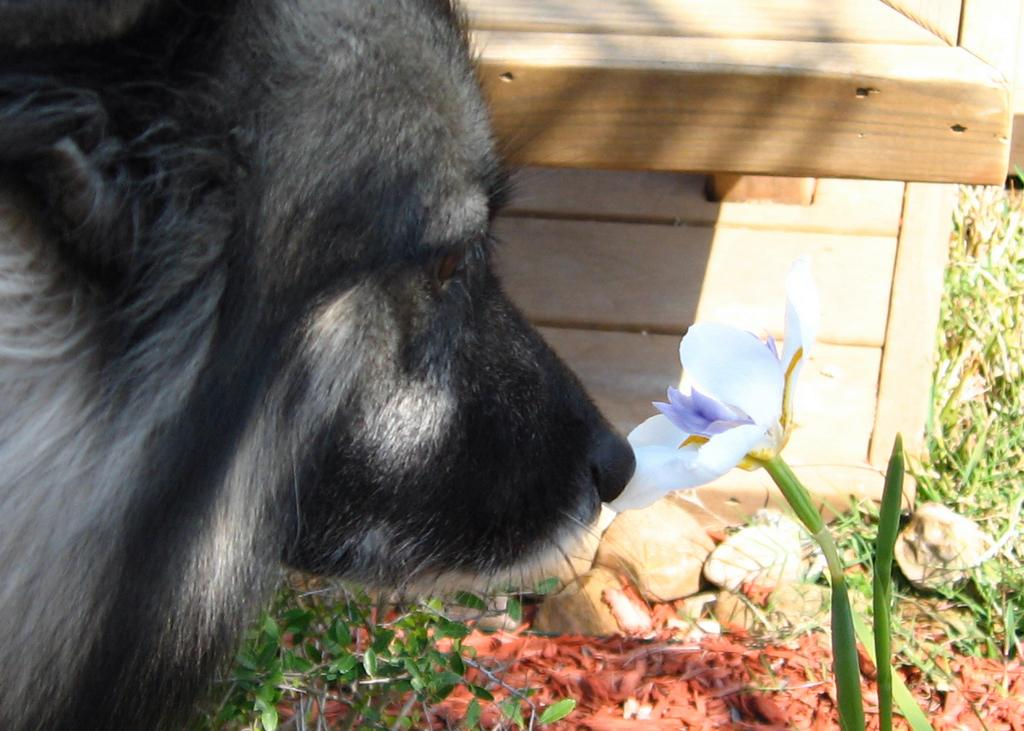What is the main subject in the center of the image? There is a dog in the center of the image. Can you describe the appearance of the dog? The dog is black and white in color. What can be seen in the background of the image? There is a wooden wall, a plant, a white-colored flower, grass, and stones in the background of the image. What word is written on the dog's collar in the image? There is no mention of a collar or any words written on it in the provided facts, so we cannot answer this question. 